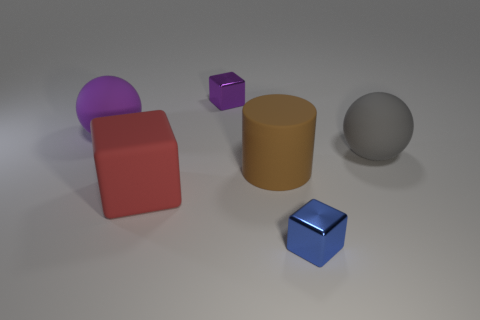Add 4 tiny blue shiny blocks. How many objects exist? 10 Subtract all red matte cubes. How many cubes are left? 2 Subtract all purple balls. How many balls are left? 1 Subtract all balls. How many objects are left? 4 Subtract all small gray metallic cylinders. Subtract all tiny things. How many objects are left? 4 Add 1 tiny objects. How many tiny objects are left? 3 Add 1 red rubber objects. How many red rubber objects exist? 2 Subtract 0 cyan cylinders. How many objects are left? 6 Subtract 2 cubes. How many cubes are left? 1 Subtract all gray cylinders. Subtract all red spheres. How many cylinders are left? 1 